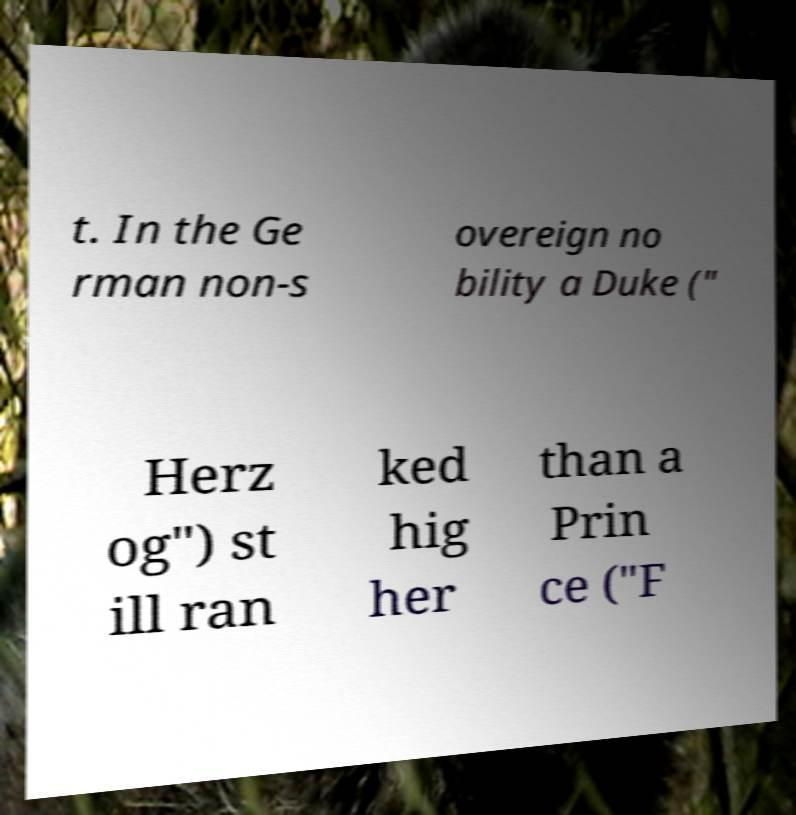For documentation purposes, I need the text within this image transcribed. Could you provide that? t. In the Ge rman non-s overeign no bility a Duke (" Herz og") st ill ran ked hig her than a Prin ce ("F 